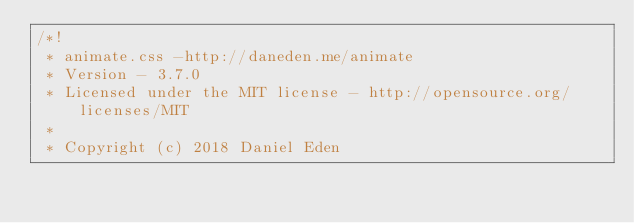Convert code to text. <code><loc_0><loc_0><loc_500><loc_500><_CSS_>/*!
 * animate.css -http://daneden.me/animate
 * Version - 3.7.0
 * Licensed under the MIT license - http://opensource.org/licenses/MIT
 *
 * Copyright (c) 2018 Daniel Eden</code> 